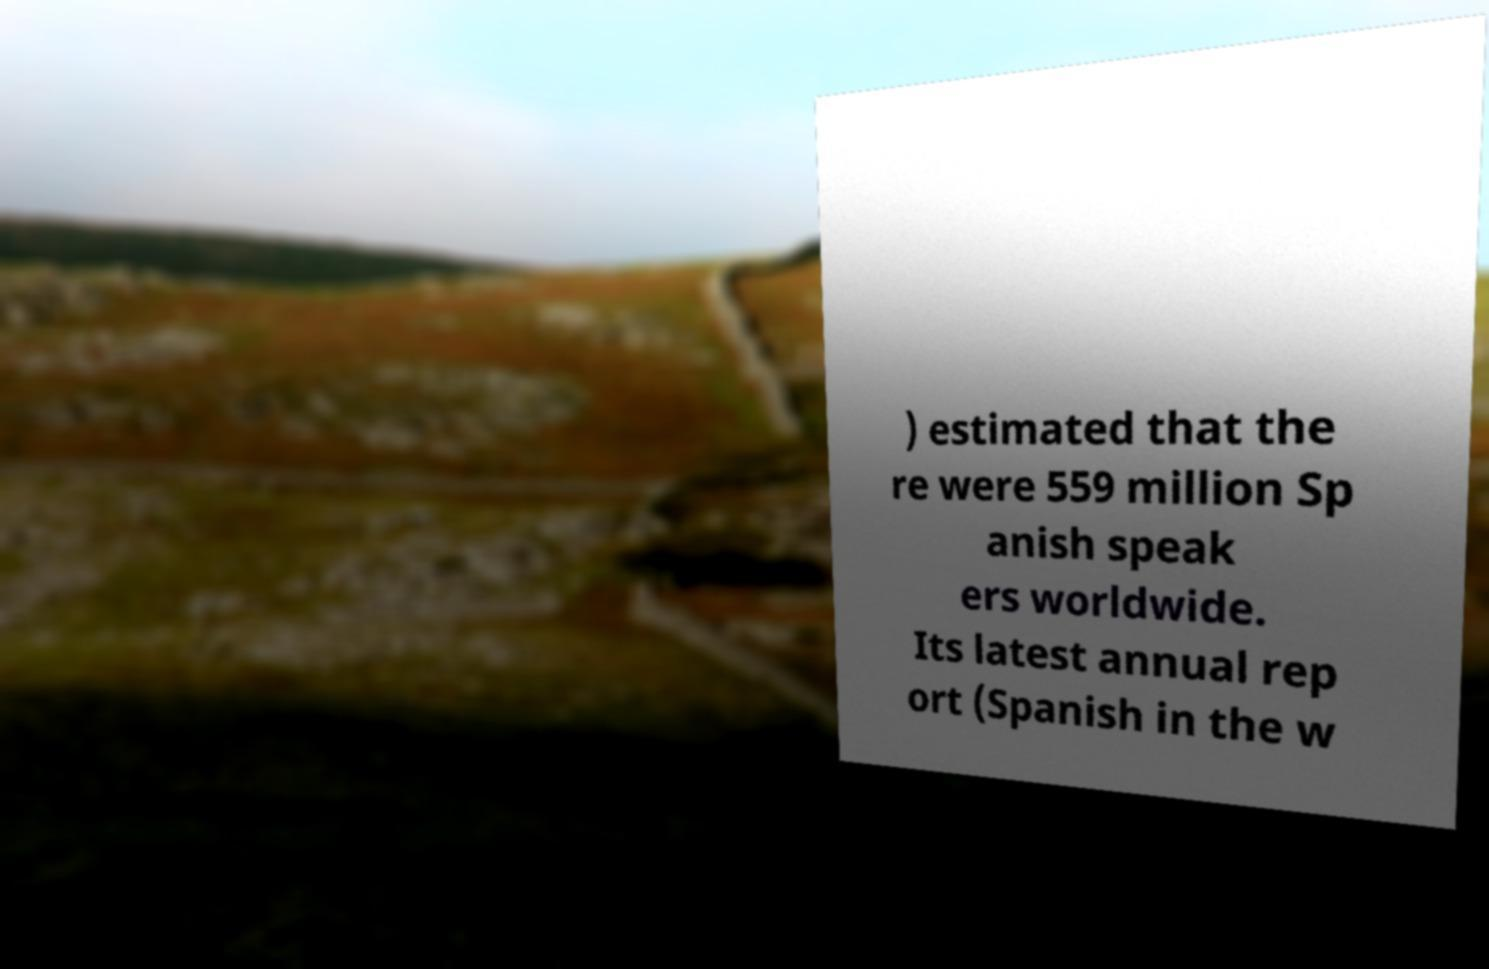Can you accurately transcribe the text from the provided image for me? ) estimated that the re were 559 million Sp anish speak ers worldwide. Its latest annual rep ort (Spanish in the w 